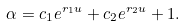<formula> <loc_0><loc_0><loc_500><loc_500>\alpha = c _ { 1 } e ^ { r _ { 1 } u } + c _ { 2 } e ^ { r _ { 2 } u } + 1 .</formula> 